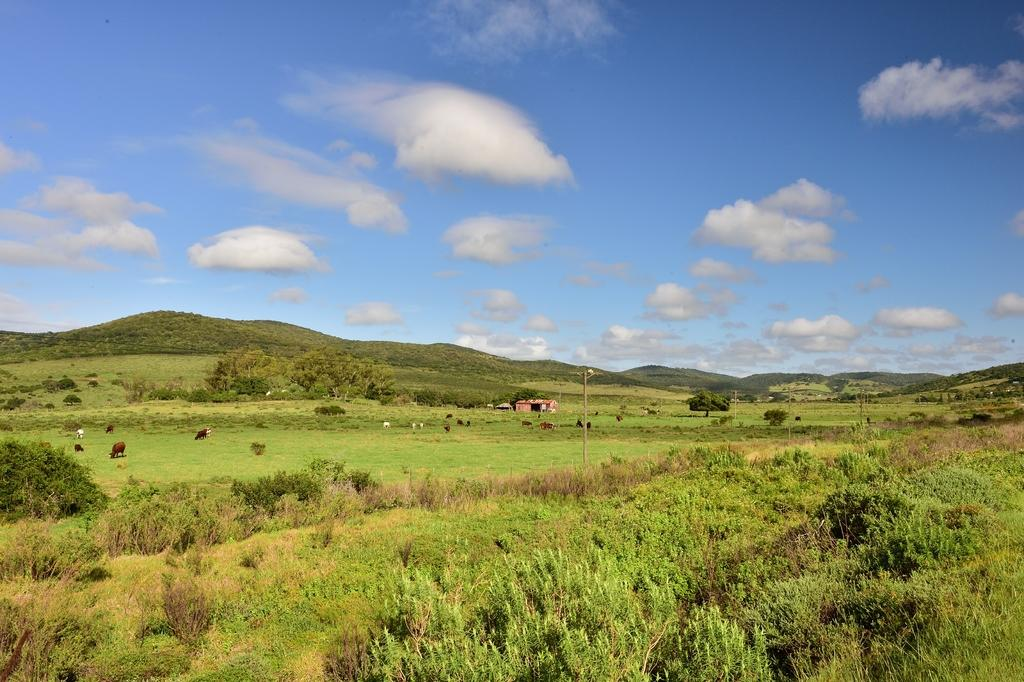What are the animals in the image doing? The animals are grazing in the image. What can be seen in the background of the image? There are trees in the background of the image. What is visible at the top of the image? The sky is visible at the top of the image. What is the weather like in the image? The sky appears to be sunny, suggesting a clear and bright day. What type of magic is being performed by the nail in the image? There is no nail present in the image, and therefore no magic can be performed by it. 